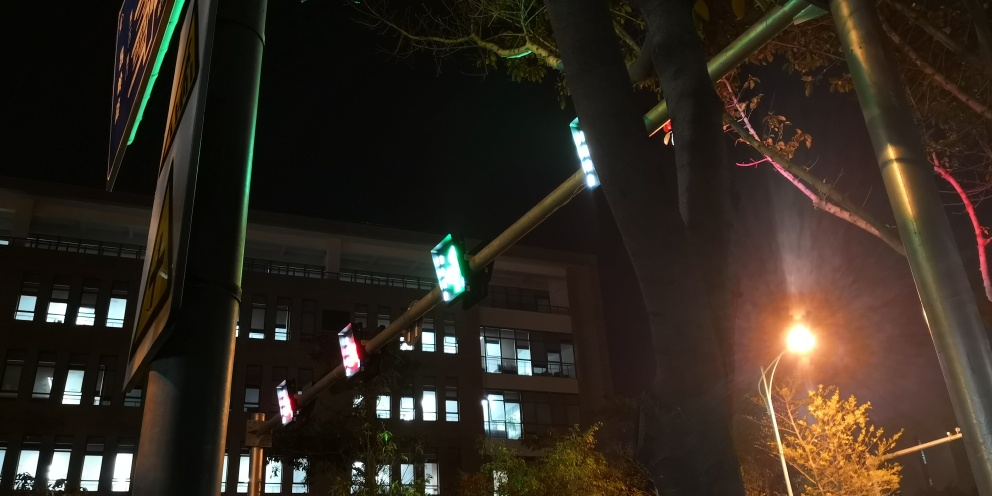What time of day does this image depict? The image captures a nighttime scene, evidenced by the artificial lighting from street lamps and traffic signals, and the apparent darkness in the sky. What does the brightness of the lights suggest about the camera's settings? The brightness of the lights, along with the visible light trails and flares, suggests that the camera's settings may include a low shutter speed or a higher ISO to capture more light, typical for night photography to compensate for low ambient light. 